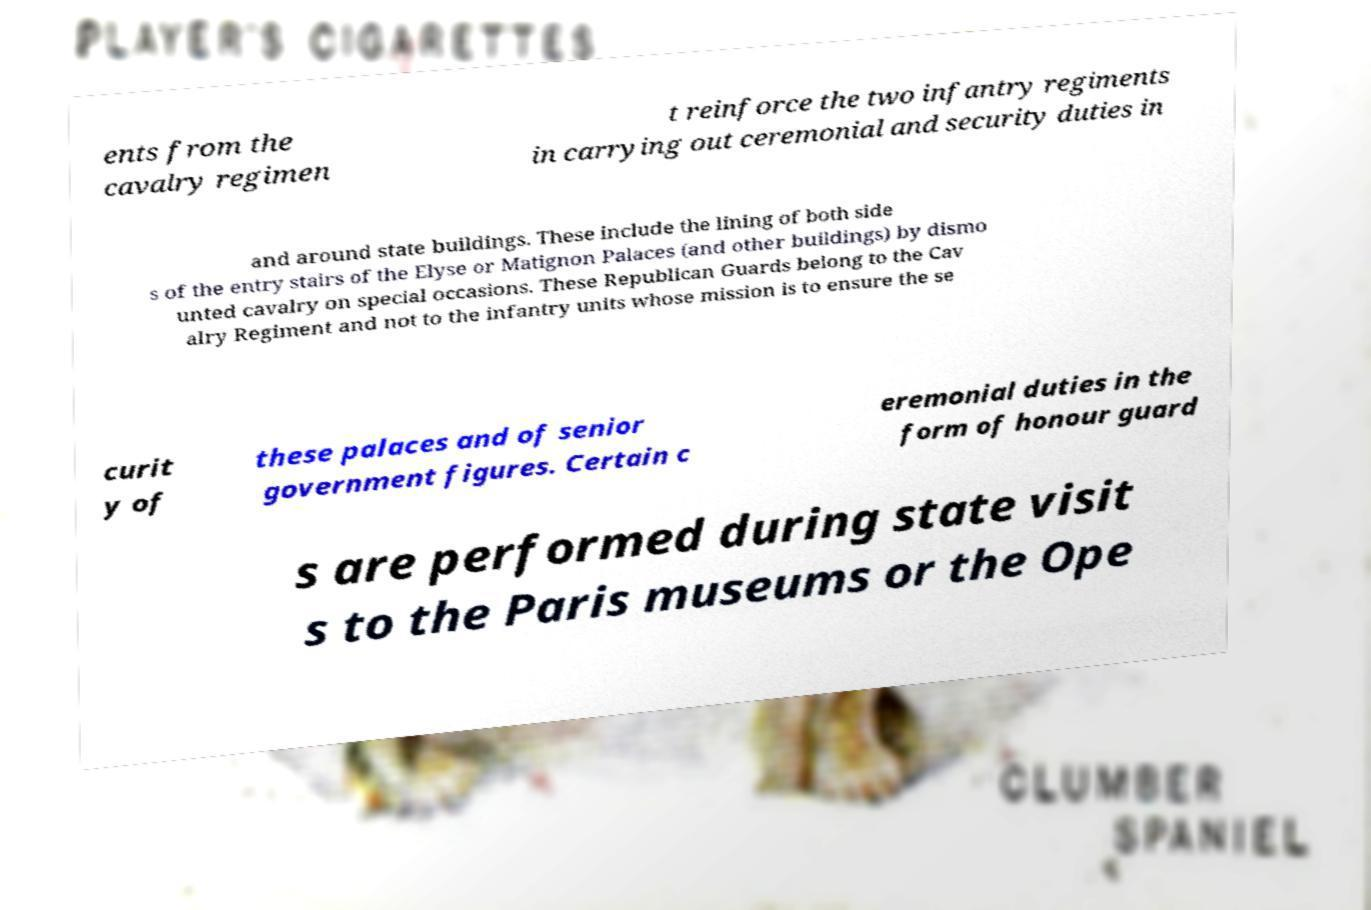Please identify and transcribe the text found in this image. ents from the cavalry regimen t reinforce the two infantry regiments in carrying out ceremonial and security duties in and around state buildings. These include the lining of both side s of the entry stairs of the Elyse or Matignon Palaces (and other buildings) by dismo unted cavalry on special occasions. These Republican Guards belong to the Cav alry Regiment and not to the infantry units whose mission is to ensure the se curit y of these palaces and of senior government figures. Certain c eremonial duties in the form of honour guard s are performed during state visit s to the Paris museums or the Ope 